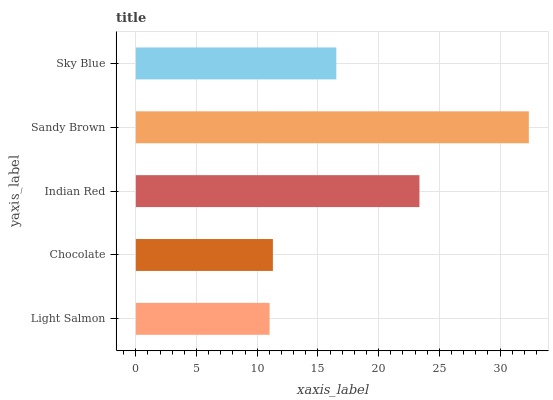Is Light Salmon the minimum?
Answer yes or no. Yes. Is Sandy Brown the maximum?
Answer yes or no. Yes. Is Chocolate the minimum?
Answer yes or no. No. Is Chocolate the maximum?
Answer yes or no. No. Is Chocolate greater than Light Salmon?
Answer yes or no. Yes. Is Light Salmon less than Chocolate?
Answer yes or no. Yes. Is Light Salmon greater than Chocolate?
Answer yes or no. No. Is Chocolate less than Light Salmon?
Answer yes or no. No. Is Sky Blue the high median?
Answer yes or no. Yes. Is Sky Blue the low median?
Answer yes or no. Yes. Is Light Salmon the high median?
Answer yes or no. No. Is Indian Red the low median?
Answer yes or no. No. 